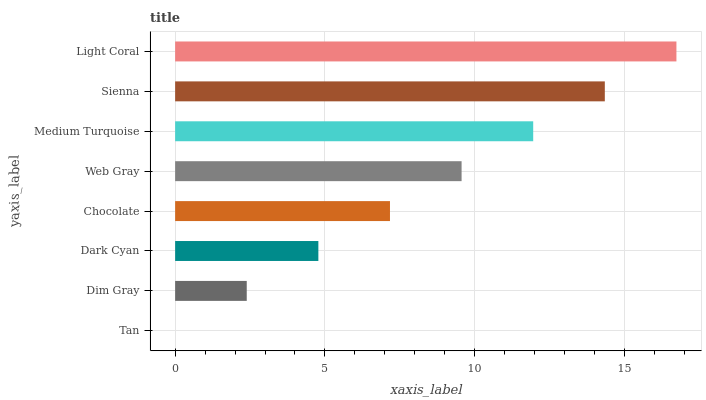Is Tan the minimum?
Answer yes or no. Yes. Is Light Coral the maximum?
Answer yes or no. Yes. Is Dim Gray the minimum?
Answer yes or no. No. Is Dim Gray the maximum?
Answer yes or no. No. Is Dim Gray greater than Tan?
Answer yes or no. Yes. Is Tan less than Dim Gray?
Answer yes or no. Yes. Is Tan greater than Dim Gray?
Answer yes or no. No. Is Dim Gray less than Tan?
Answer yes or no. No. Is Web Gray the high median?
Answer yes or no. Yes. Is Chocolate the low median?
Answer yes or no. Yes. Is Dark Cyan the high median?
Answer yes or no. No. Is Dim Gray the low median?
Answer yes or no. No. 